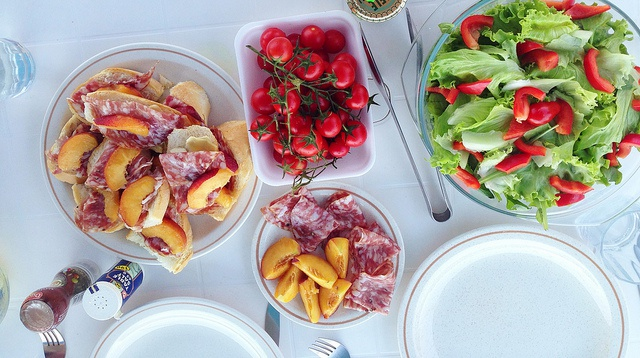Describe the objects in this image and their specific colors. I can see dining table in lightgray, lightblue, darkgray, and brown tones, bowl in lightblue, olive, lightgreen, and darkgray tones, bowl in lightblue, darkgray, brown, and tan tones, bowl in lightblue, brown, maroon, lavender, and black tones, and bowl in lightblue, brown, darkgray, lightgray, and orange tones in this image. 